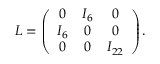Convert formula to latex. <formula><loc_0><loc_0><loc_500><loc_500>L = \left ( \begin{array} { c c c } { 0 } & { { I _ { 6 } } } & { 0 } \\ { { I _ { 6 } } } & { 0 } & { 0 } \\ { 0 } & { 0 } & { { I _ { 2 2 } } } \end{array} \right ) .</formula> 